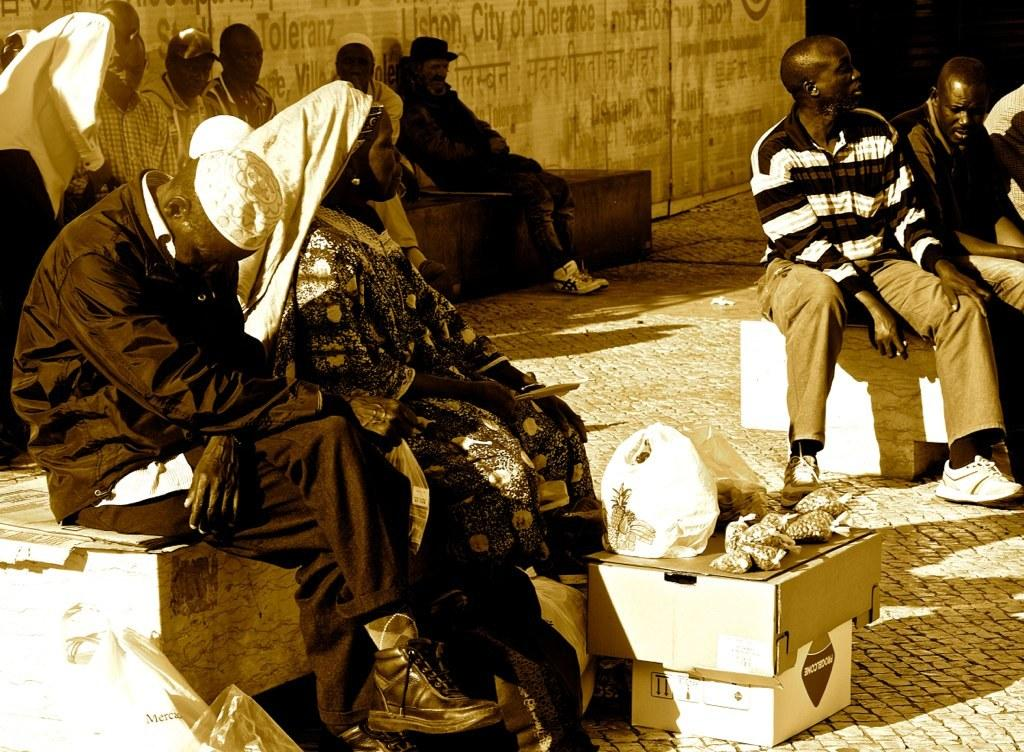What are the people in the image doing? There is a group of people sitting in the image. What is covering some of the items in the image? Plastic covers are visible in the image. What type of objects can be seen in the image? Boxes are present in the image. What else can be seen in the image besides the people and boxes? There are food items in the image. What can be seen in the background of the image? There is a wall in the background of the image. What type of flesh can be seen in the image? There is no flesh present in the image; it features a group of people sitting, plastic covers, boxes, food items, and a wall in the background. 